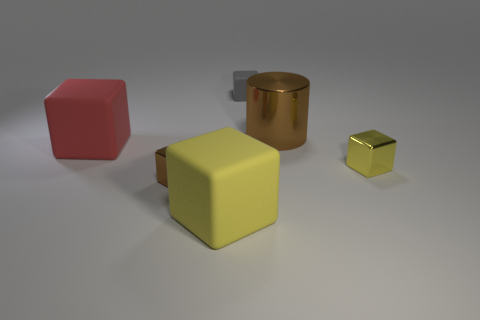Subtract all brown blocks. How many blocks are left? 4 Subtract all brown shiny blocks. How many blocks are left? 4 Subtract all blue cubes. Subtract all blue cylinders. How many cubes are left? 5 Add 2 matte objects. How many objects exist? 8 Subtract all cubes. How many objects are left? 1 Subtract all small blocks. Subtract all large red spheres. How many objects are left? 3 Add 4 tiny metal objects. How many tiny metal objects are left? 6 Add 4 yellow metallic things. How many yellow metallic things exist? 5 Subtract 0 yellow spheres. How many objects are left? 6 